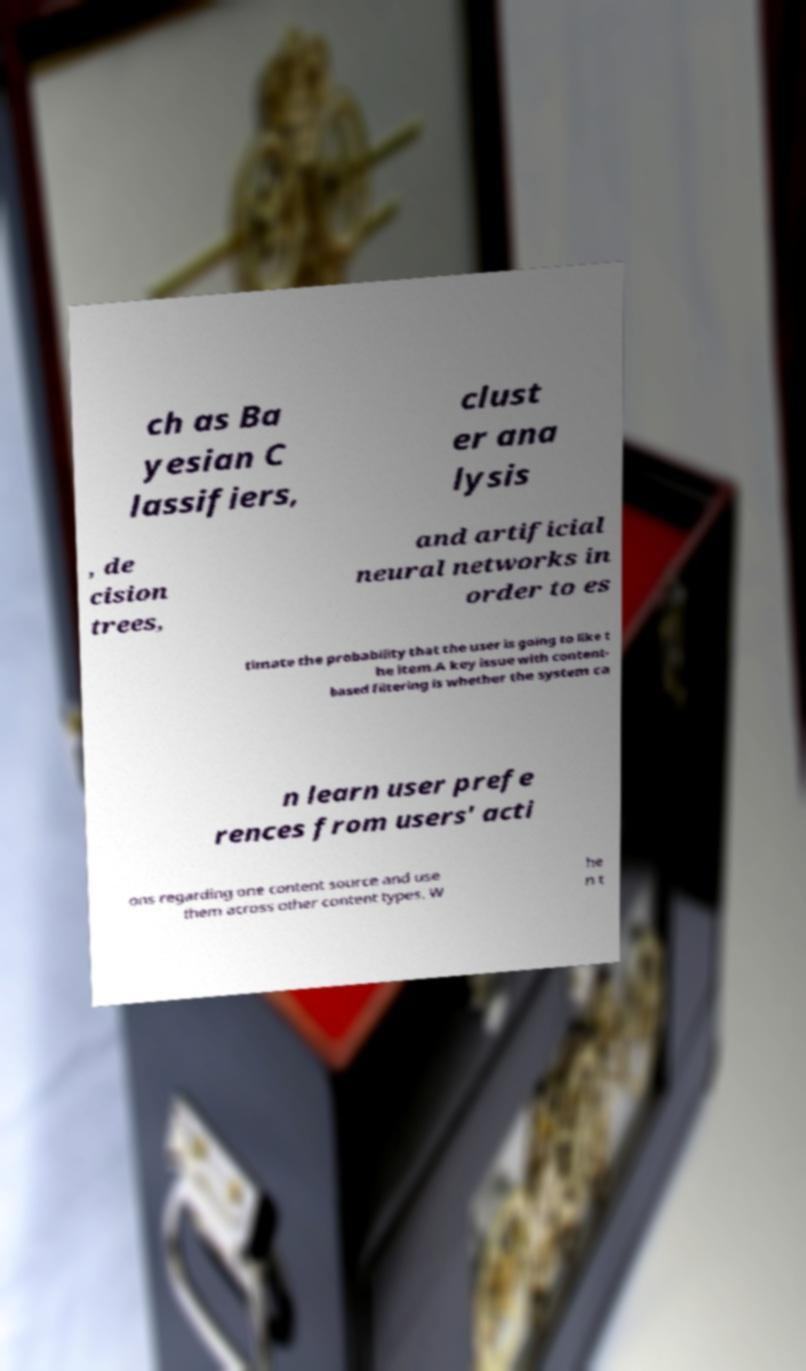Can you accurately transcribe the text from the provided image for me? ch as Ba yesian C lassifiers, clust er ana lysis , de cision trees, and artificial neural networks in order to es timate the probability that the user is going to like t he item.A key issue with content- based filtering is whether the system ca n learn user prefe rences from users' acti ons regarding one content source and use them across other content types. W he n t 